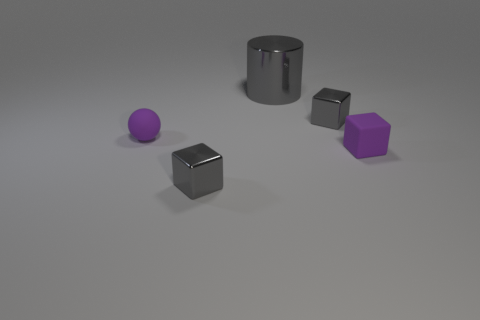Add 3 cylinders. How many objects exist? 8 Subtract all gray cubes. How many cubes are left? 1 Subtract all balls. How many objects are left? 4 Add 4 big purple rubber balls. How many big purple rubber balls exist? 4 Subtract 0 red spheres. How many objects are left? 5 Subtract all purple rubber objects. Subtract all gray shiny cylinders. How many objects are left? 2 Add 5 tiny gray objects. How many tiny gray objects are left? 7 